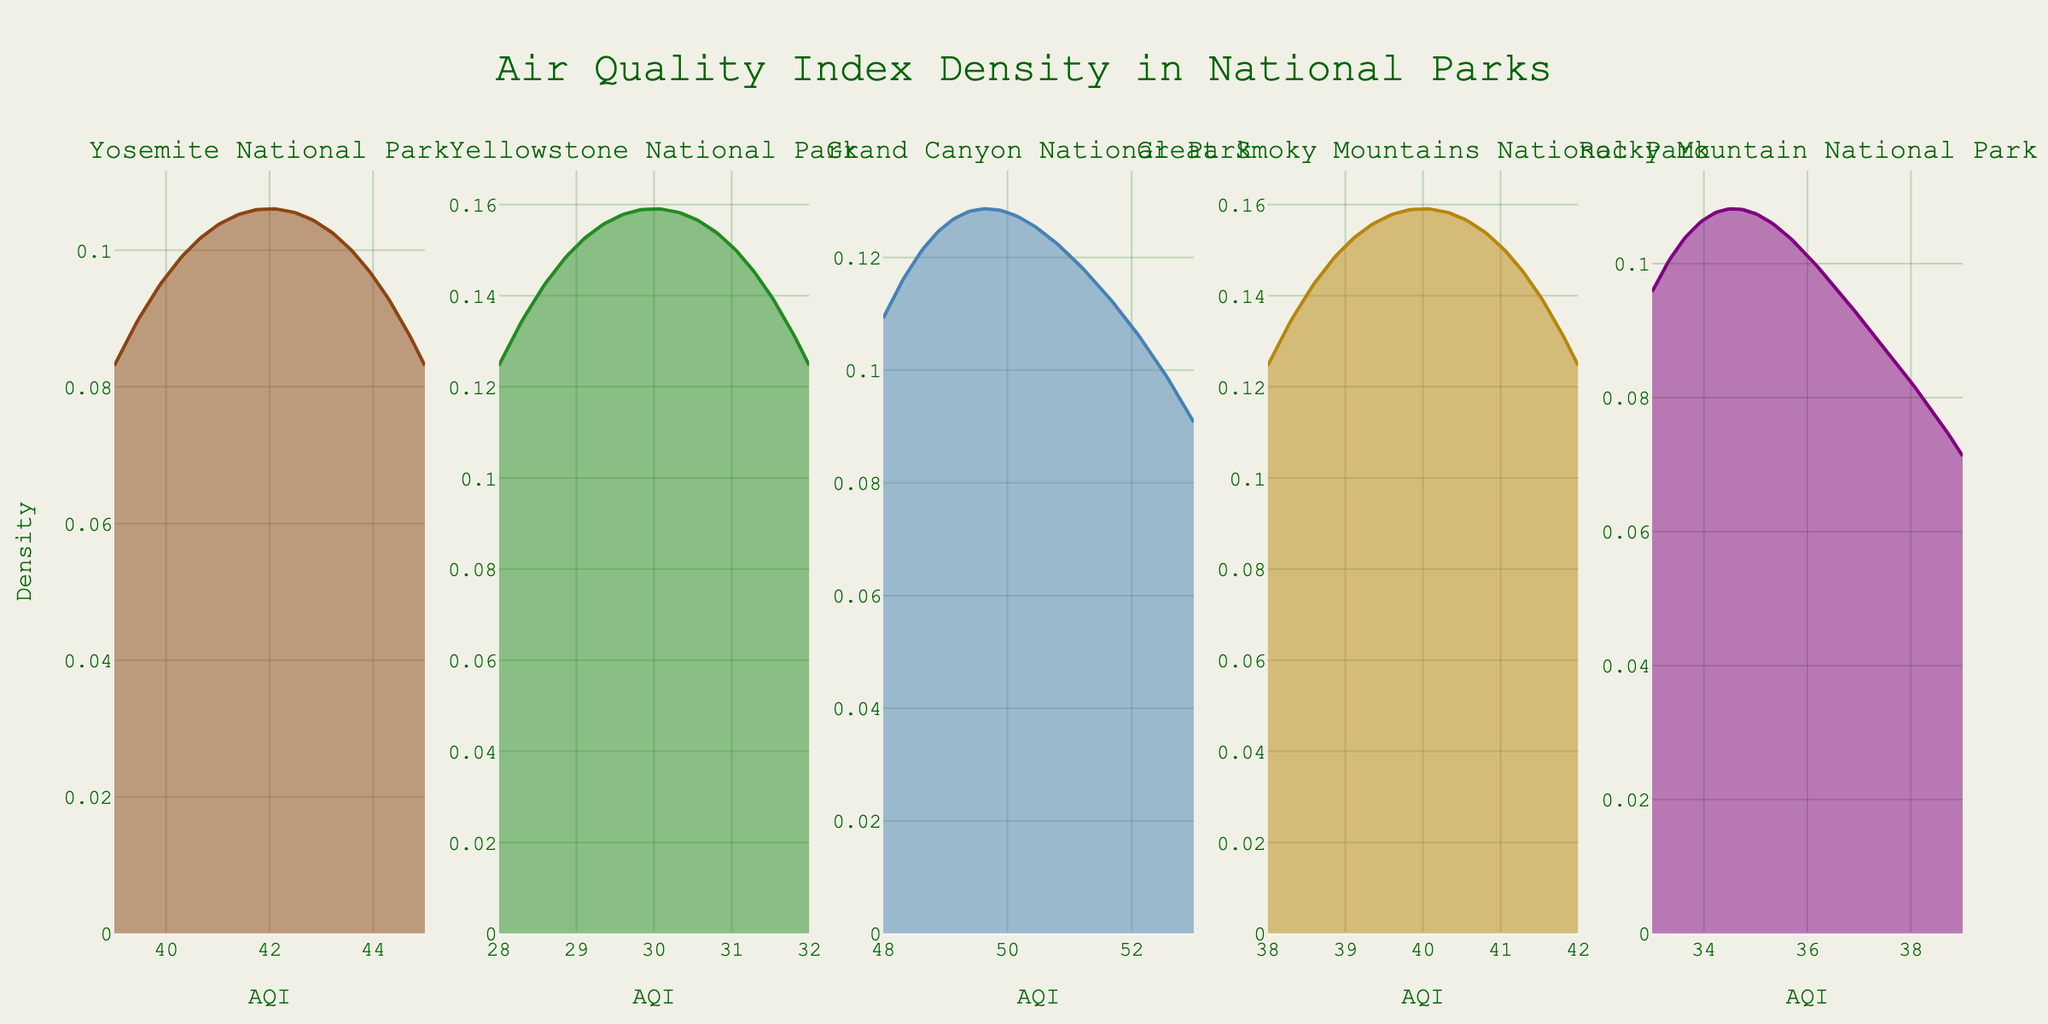What is the title of the figure? The title of the figure is usually displayed at the top. It summarizes what the figure is about.
Answer: Air Quality Index Density in National Parks Which national park has the highest peak in its density plot? Identify the highest point (peak) on each density plot, then compare them to determine which is the highest.
Answer: Grand Canyon National Park What are the AQI values covered in the density plot for Yosemite National Park? The range of AQI values can be determined by looking at the x-axis of the density plot specific to Yosemite National Park.
Answer: 39 to 45 Among the national parks, which one shows the lowest AQI peak value? Determine the minimum value from the peaks listed in each density plot segment.
Answer: Yellowstone National Park How does the density for Great Smoky Mountains National Park differ from that of Rocky Mountain National Park? Compare the shapes and peak points of the density plots for both parks. Look for differences in height and distribution.
Answer: Great Smoky Mountains has a more spread distribution compared to the sharper peak of Rocky Mountain Which national park shows the most variability in AQI based on its density plot? Look at the width and spread of the density plot: a wider spread indicates more variability.
Answer: Great Smoky Mountains National Park If you were to compare the AQI densities of Yosemite and Yellowstone, which has a more consistent (less variable) AQI? Determine which park’s density plot has a narrower and taller shape, indicating less variability.
Answer: Yosemite National Park Which national park's density plot appears to have the tightest clustering around its peak? Identify the park whose density plot is most narrow and highest at the peak, suggesting tight clustering.
Answer: Grand Canyon National Park 